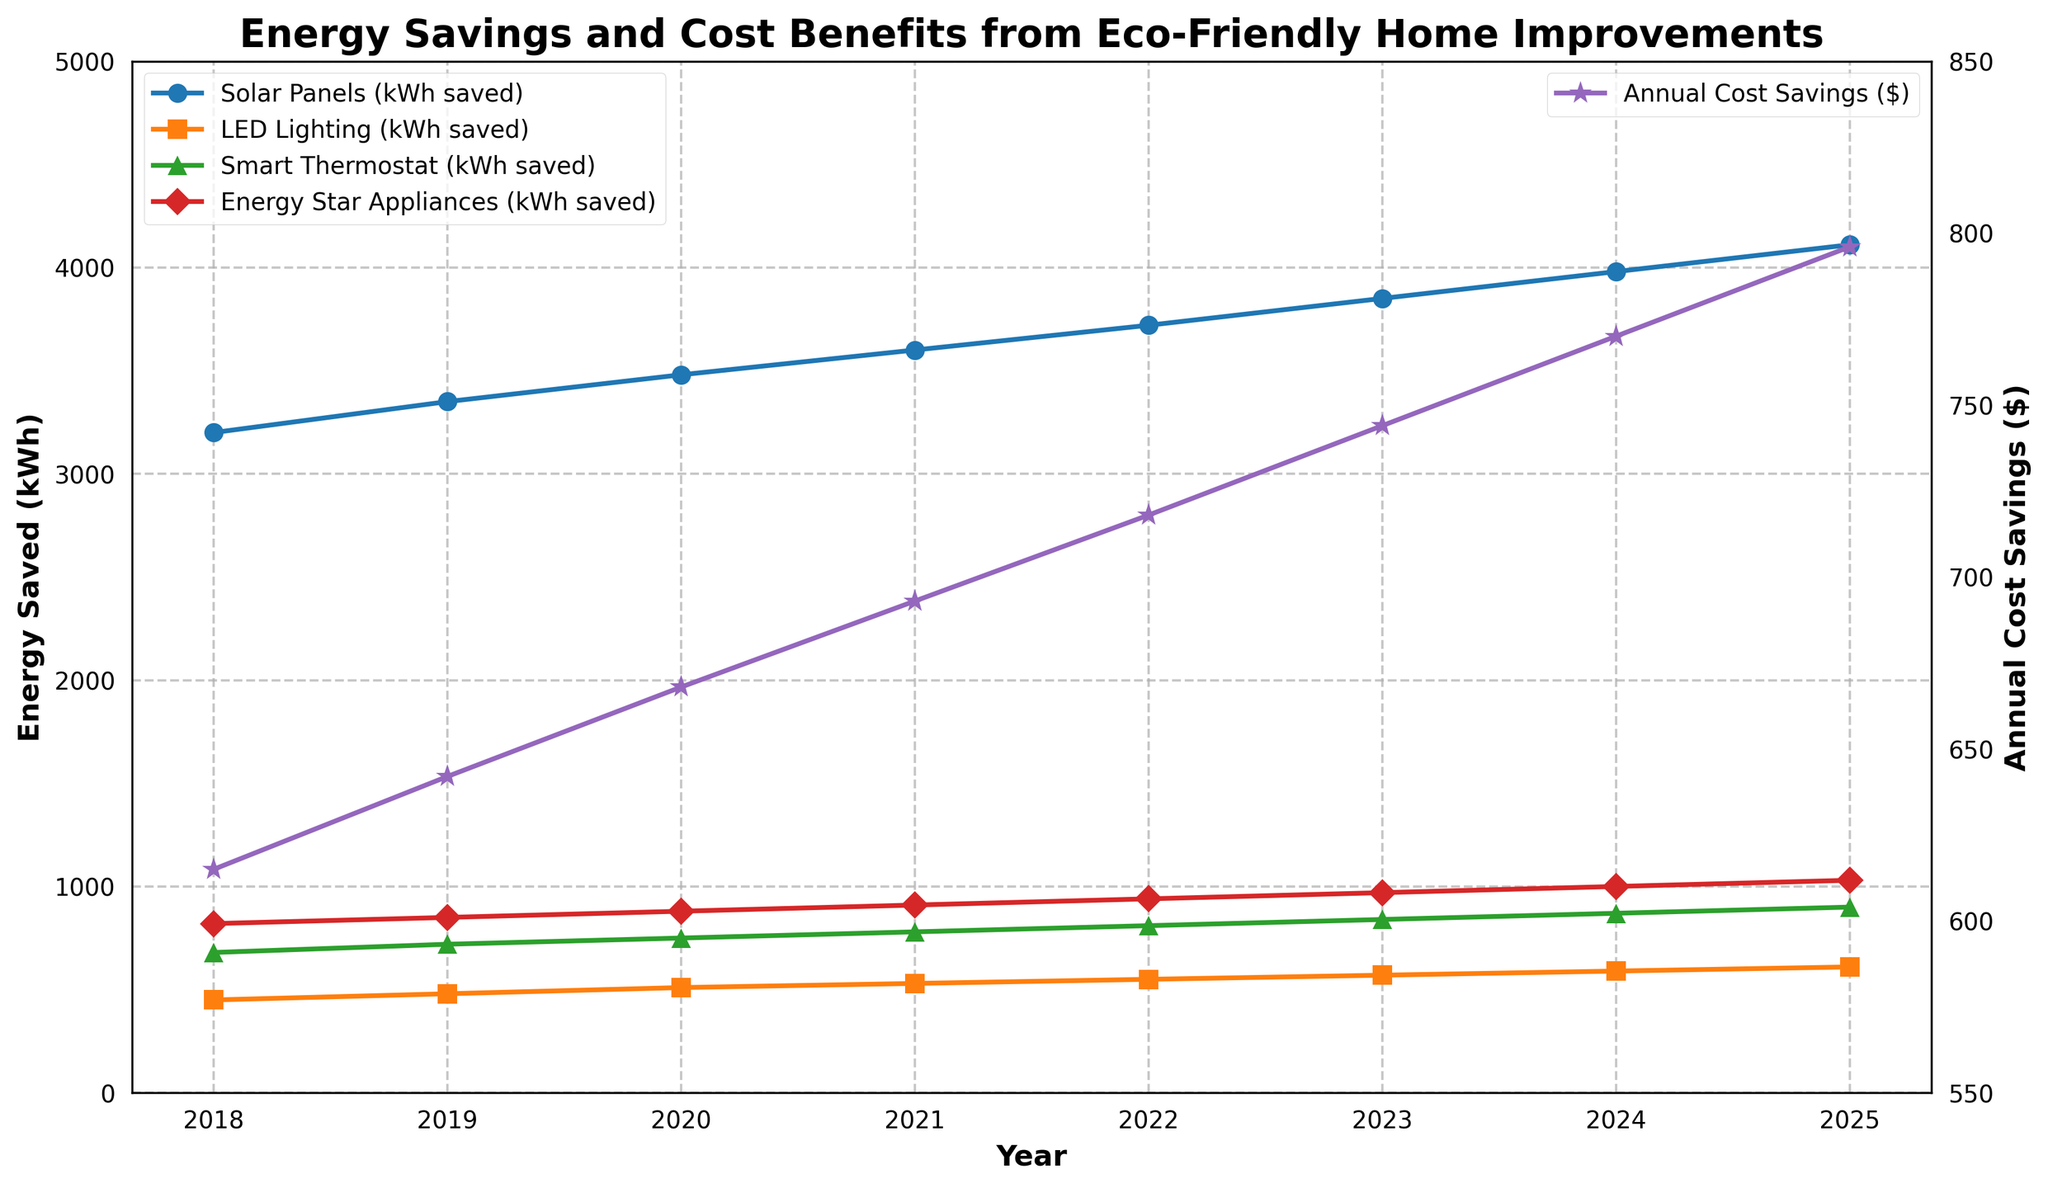How has the annual cost savings changed from 2018 to 2025? Look at the curve representing 'Annual Cost Savings ($)' with markers and measure the difference in the y-axis values from 2018 to 2025. It starts at $615 and ends at $796.
Answer: Increased by $181 What year saw the highest kWh saved by Solar Panels? Examine the line corresponding to 'Solar Panels (kWh saved)' and find the peak value. The highest occurs in 2025 with 4110 kWh saved.
Answer: 2025 Which home improvement shows the least variation in kWh saved from 2018 to 2025? Compare the vertical distance between the starting and ending points of each line. 'LED Lighting (kWh saved)' has the smallest change, from 450 kWh in 2018 to 610 kWh in 2025, a difference of 160 kWh.
Answer: LED Lighting How do Smart Thermostat savings in 2024 compare to those in 2019? Look at the 'Smart Thermostat (kWh saved)' data points for 2024 and 2019 on the chart. In 2024, the savings are 870 kWh, while in 2019, they are 720 kWh.
Answer: 150 kWh more What is the average annual cost savings from 2018 to 2025? Sum the annual savings values from the figure and divide by the number of years (8). The values are $615 + $642 + $668 + $693 + $718 + $744 + $770 + $796, which totals to $5646. Dividing by 8 gives $705.75.
Answer: $705.75 Which year experienced the greatest increase in cost savings from the previous year? Calculate the difference year over year and compare. From 2018 to 2019, the increase was $27; 2019 to 2020 was $26; 2020 to 2021 was $25; 2021 to 2022 was $25; 2022 to 2023 was $26; 2023 to 2024 was $26; 2024 to 2025 was $26. The greatest increase was from 2018 to 2019.
Answer: 2019 Among the four home improvements, which had the most consistent increase in kWh saved over the years? Observe the slopes of the lines representing each series. 'Solar Panels (kWh saved)' shows the most linear and consistent increase over the years.
Answer: Solar Panels How do the energy savings for Energy Star Appliances in 2022 compare to those for LED Lighting in 2024? Find the data point values for each year. Energy Star Appliances in 2022 saved 940 kWh, while LED Lighting in 2024 saved 590 kWh. Subtract the two values: 940 - 590.
Answer: 350 kWh more What is the overall increase in kWh saved by Smart Thermostats from 2018 to 2025? Calculate the difference between the kWh saved in 2025 and 2018 for Smart Thermostats. The values are 900 kWh in 2025 and 680 kWh in 2018, so 900 - 680.
Answer: 220 kWh 